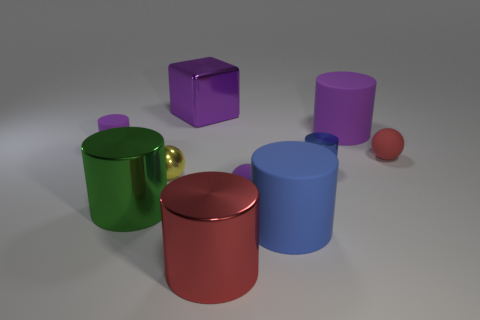Subtract all blue cylinders. How many cylinders are left? 4 Subtract all blue cylinders. How many cylinders are left? 4 Subtract 1 cylinders. How many cylinders are left? 5 Subtract all blue cylinders. Subtract all red balls. How many cylinders are left? 4 Subtract all cubes. How many objects are left? 9 Subtract 0 blue balls. How many objects are left? 10 Subtract all large blue rubber cylinders. Subtract all large red metallic cylinders. How many objects are left? 8 Add 8 small matte spheres. How many small matte spheres are left? 10 Add 4 blue objects. How many blue objects exist? 6 